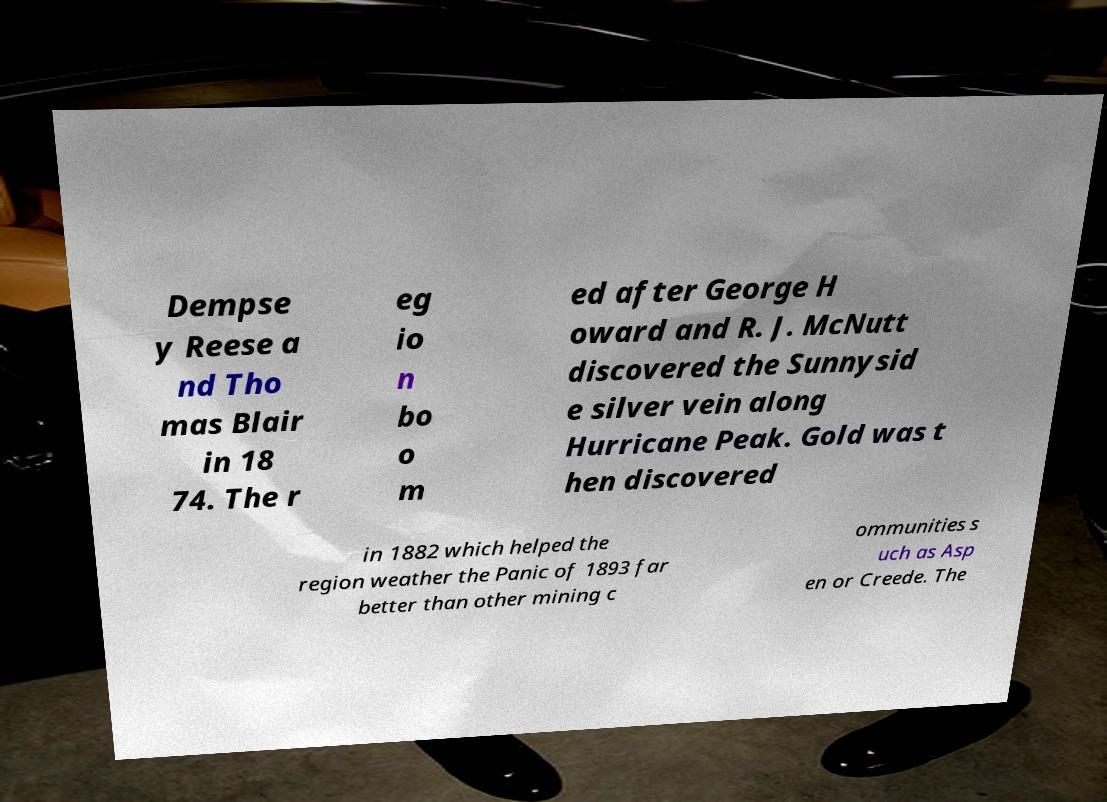Could you extract and type out the text from this image? Dempse y Reese a nd Tho mas Blair in 18 74. The r eg io n bo o m ed after George H oward and R. J. McNutt discovered the Sunnysid e silver vein along Hurricane Peak. Gold was t hen discovered in 1882 which helped the region weather the Panic of 1893 far better than other mining c ommunities s uch as Asp en or Creede. The 